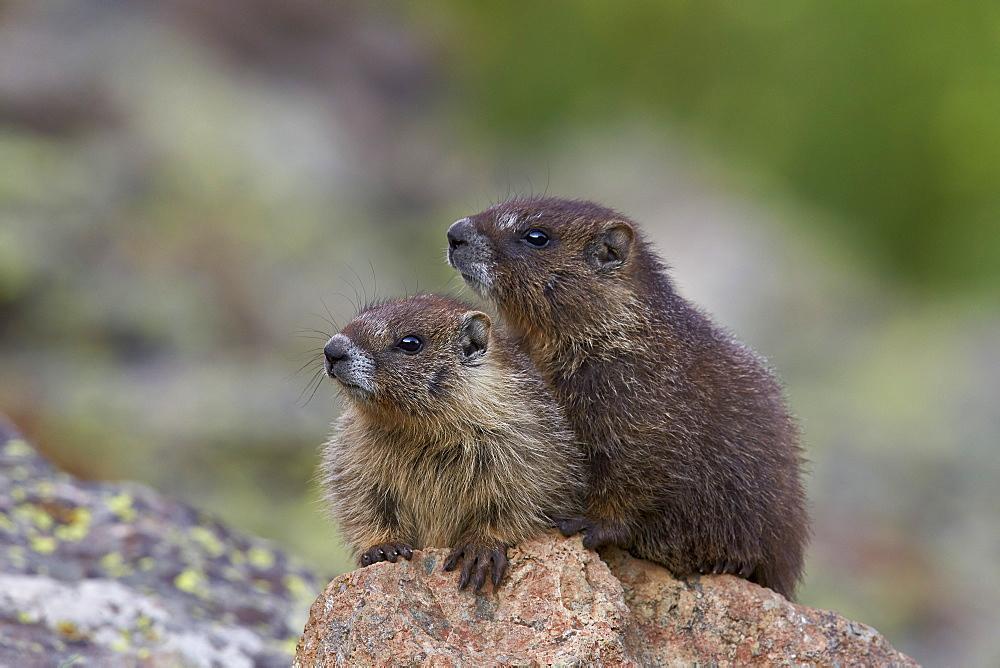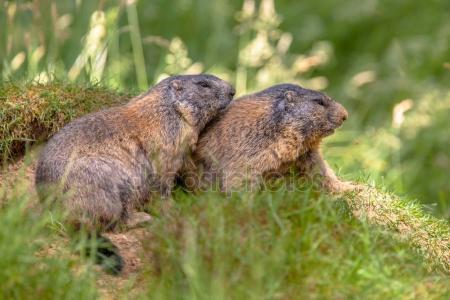The first image is the image on the left, the second image is the image on the right. Examine the images to the left and right. Is the description "Marmots are standing on hind legs facing each other" accurate? Answer yes or no. No. The first image is the image on the left, the second image is the image on the right. Given the left and right images, does the statement "There are 3 groundhogs that are not touching another groundhog." hold true? Answer yes or no. No. 